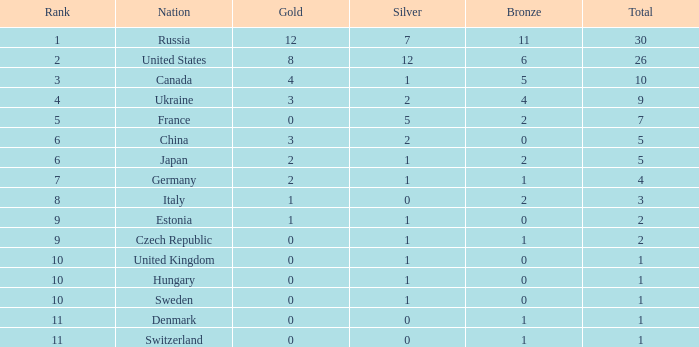What is the biggest silver with gold greater than 4, a united states nation, and a total exceeding 26? None. 